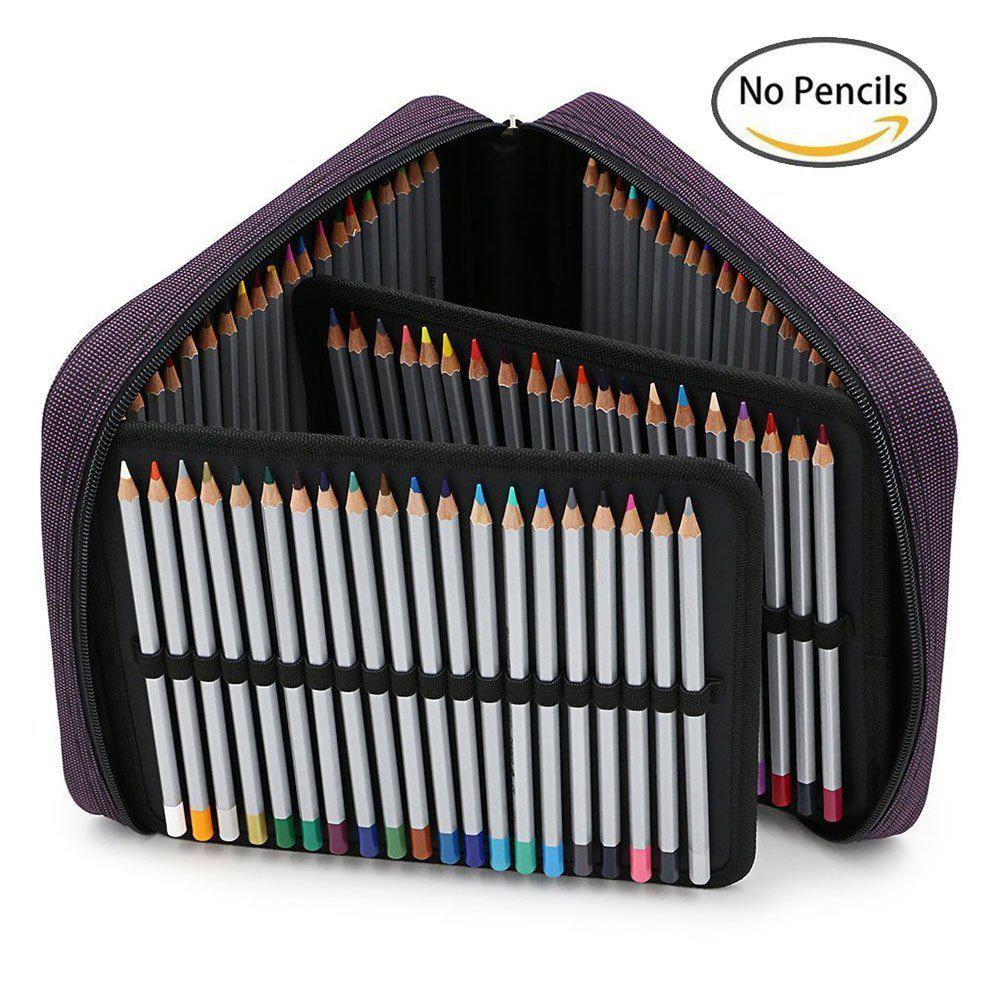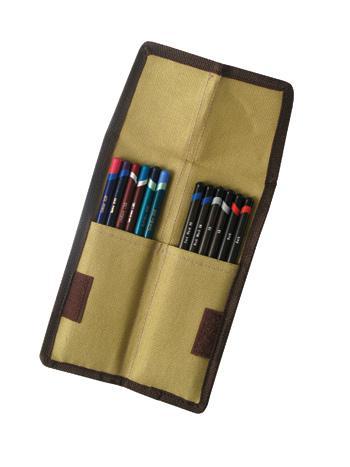The first image is the image on the left, the second image is the image on the right. Given the left and right images, does the statement "Some of the pencils are completely out of the case in one of the images." hold true? Answer yes or no. No. The first image is the image on the left, the second image is the image on the right. Considering the images on both sides, is "One image shows a fold-out pencil case forming a triangle shape and filled with colored-lead pencils." valid? Answer yes or no. Yes. 